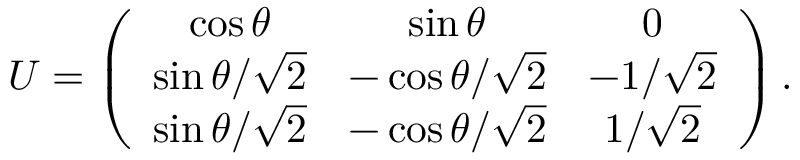Convert formula to latex. <formula><loc_0><loc_0><loc_500><loc_500>U = \left ( \begin{array} { c c c } { \cos \theta } & { \sin \theta } & { 0 } \\ { { \sin \theta / \sqrt { 2 } } } & { { - \cos \theta / \sqrt { 2 } } } & { { - 1 / \sqrt { 2 } } } \\ { { \sin \theta / \sqrt { 2 } } } & { { - \cos \theta / \sqrt { 2 } } } & { { 1 / \sqrt { 2 } } } \end{array} \right ) .</formula> 